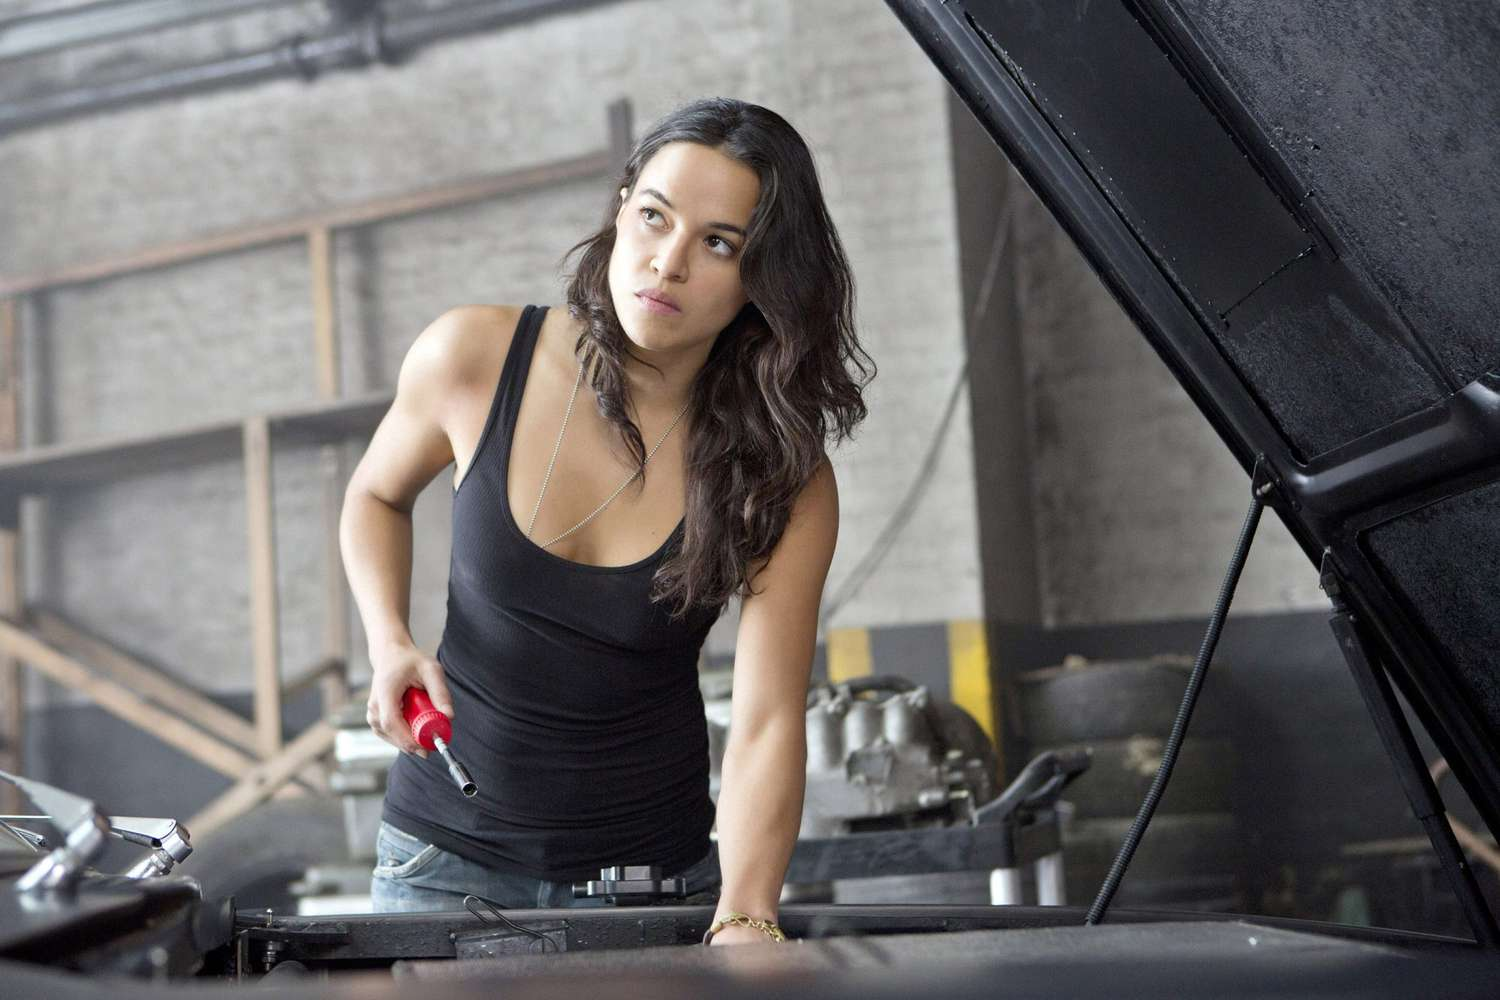Describe the expression on the woman's face. The woman has a serious and focused expression on her face. Her brows are slightly furrowed and her gaze is directed intently at the task before her, demonstrating her concentration and determination. This intense look suggests that she is deeply immersed in her work, possibly troubleshooting an issue or ensuring that every detail is perfect as she works on the car. What might be the significance of her holding a red wrench? The red wrench she is holding could symbolize her proficiency and readiness for the task at hand. Tools like wrenches are essential in automotive repair, and the bright red color may signify her bold, hands-on approach to problem-solving. It could also highlight her personal style, suggesting that she combines practicality with a touch of individuality in her work. Additionally, the color red is often associated with energy and determination, which aligns with her focused and dedicated demeanor. Imagine a scenario where the red wrench has a hidden feature. In a novel twist, the red wrench in her hand isn't just an ordinary tool. Embedded within its handle is advanced technology that allows it to scan and diagnose the car's internal systems, pinpointing issues with unparalleled accuracy. It even contains a small AI assistant that provides real-time guidance and suggestions. This hidden feature transforms the wrench into a powerful diagnostic device that can expedite the repair process, making her work more efficient and precise. The woman discovered this unique tool in a forgotten corner of a vintage automotive shop, and it has since been her secret weapon in tackling the most challenging automotive issues. 